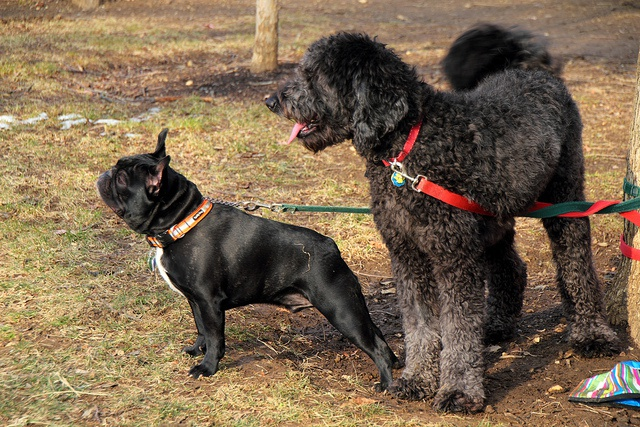Describe the objects in this image and their specific colors. I can see dog in brown, black, gray, and maroon tones and dog in brown, black, and gray tones in this image. 